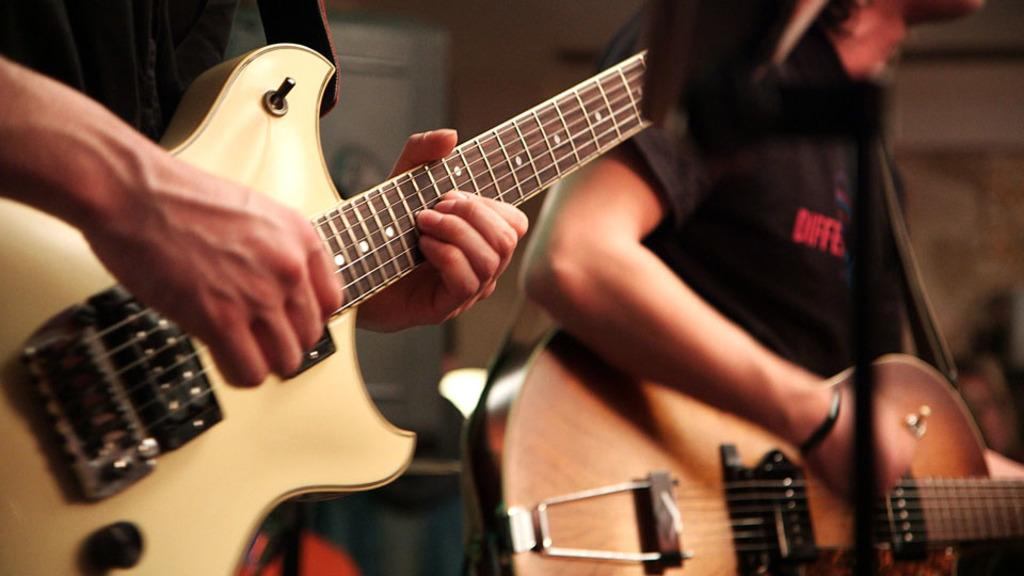How many people are in the image? There are two persons in the image. What are the persons holding in the image? Each person is holding a guitar. What are the persons doing with the guitars? The persons are playing the guitar. What type of paper can be seen hanging from the arch in the image? There is no paper or arch present in the image; it features two persons playing guitars. 